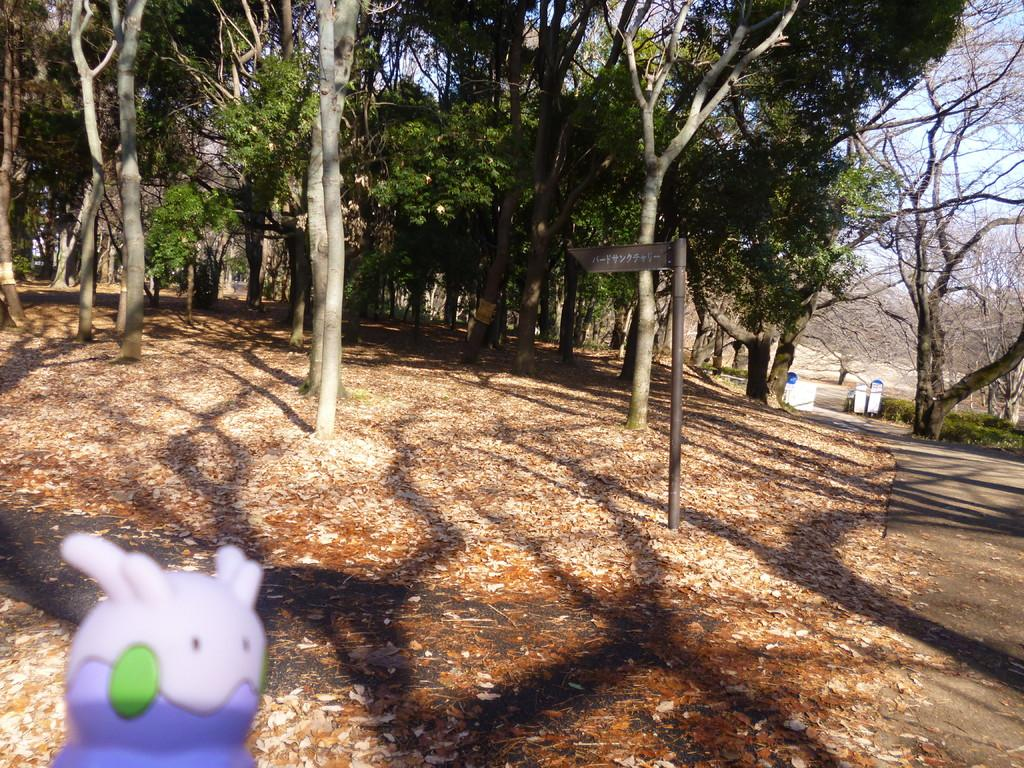What type of vegetation is present in the image? There are many trees in the image. What objects are used for waste disposal in the image? There are trash bins in the image. What type of toy can be seen in the image? There is a rubber toy in the image. What vertical structure is present in the image? There is a pole in the image. What natural debris is visible at the bottom of the image? Dried leaves are visible at the bottom of the image. What type of pathway is present in the image? There is a road in the image. Can you see a suit hanging on the trees in the image? There is no suit hanging on the trees in the image. Is there a seashore visible in the image? There is no seashore present in the image. 